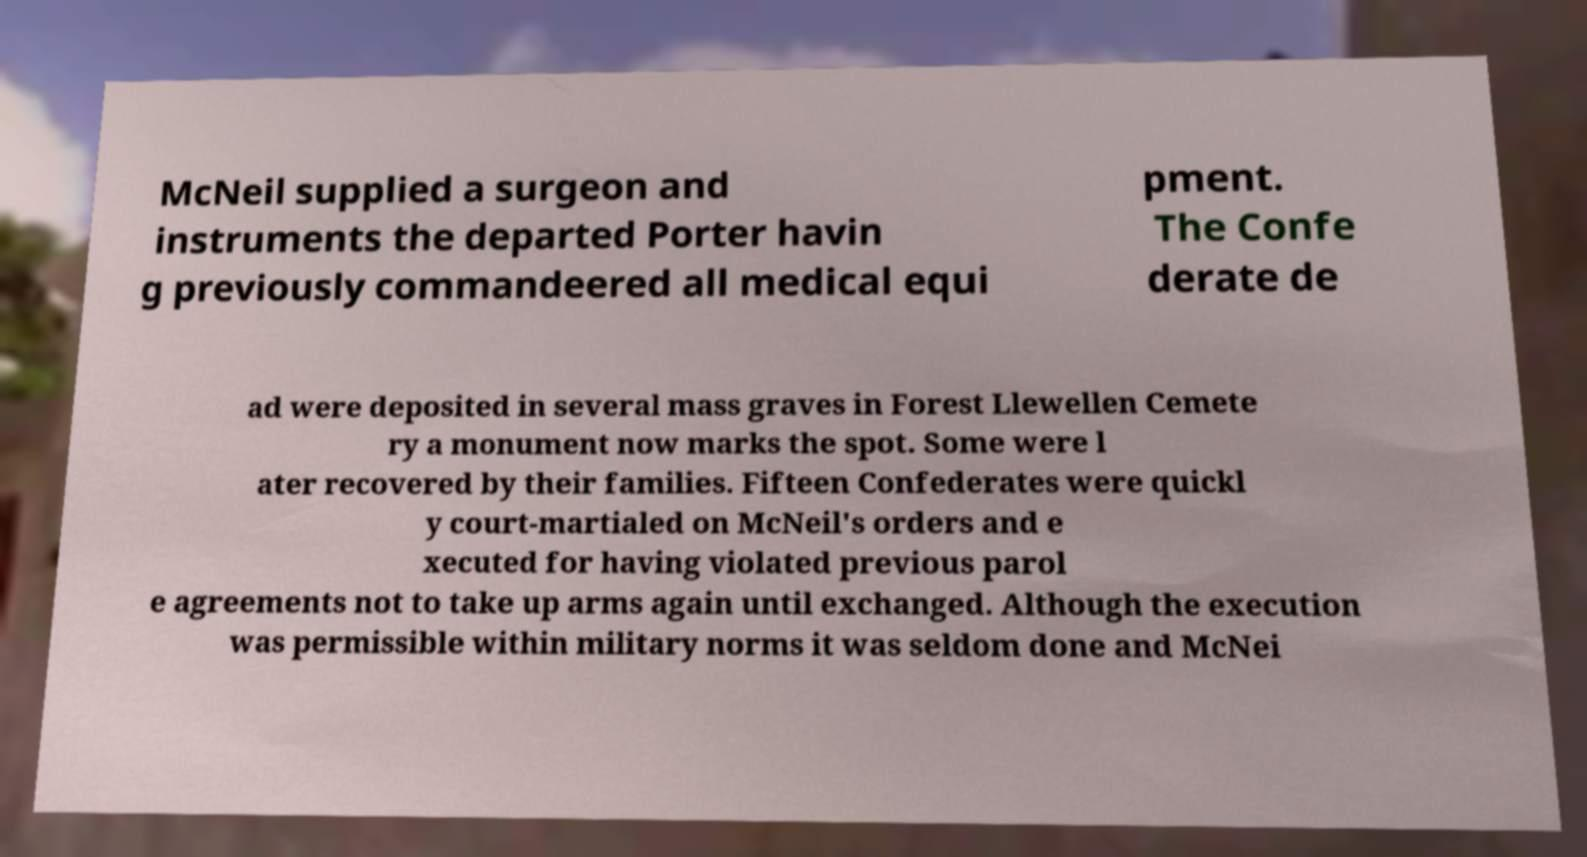For documentation purposes, I need the text within this image transcribed. Could you provide that? McNeil supplied a surgeon and instruments the departed Porter havin g previously commandeered all medical equi pment. The Confe derate de ad were deposited in several mass graves in Forest Llewellen Cemete ry a monument now marks the spot. Some were l ater recovered by their families. Fifteen Confederates were quickl y court-martialed on McNeil's orders and e xecuted for having violated previous parol e agreements not to take up arms again until exchanged. Although the execution was permissible within military norms it was seldom done and McNei 